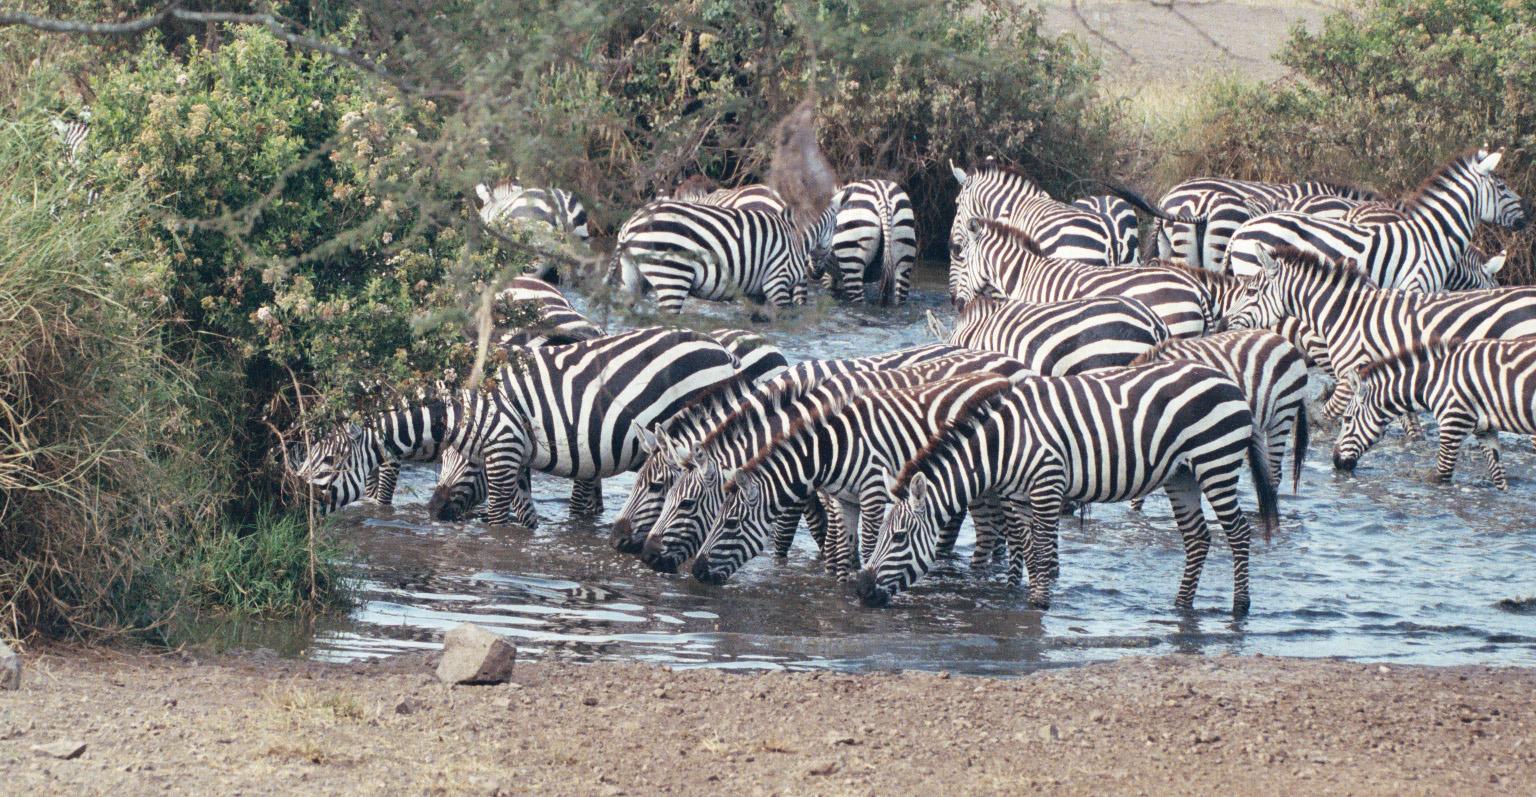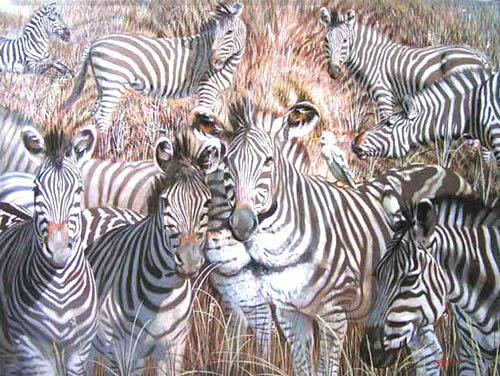The first image is the image on the left, the second image is the image on the right. Assess this claim about the two images: "The right image shows zebras lined up with heads bent to the water, and the left image shows zebras en masse with nothing else in the picture.". Correct or not? Answer yes or no. No. 